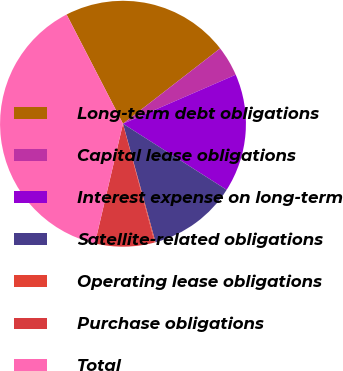<chart> <loc_0><loc_0><loc_500><loc_500><pie_chart><fcel>Long-term debt obligations<fcel>Capital lease obligations<fcel>Interest expense on long-term<fcel>Satellite-related obligations<fcel>Operating lease obligations<fcel>Purchase obligations<fcel>Total<nl><fcel>22.09%<fcel>3.97%<fcel>15.56%<fcel>11.7%<fcel>0.11%<fcel>7.83%<fcel>38.74%<nl></chart> 